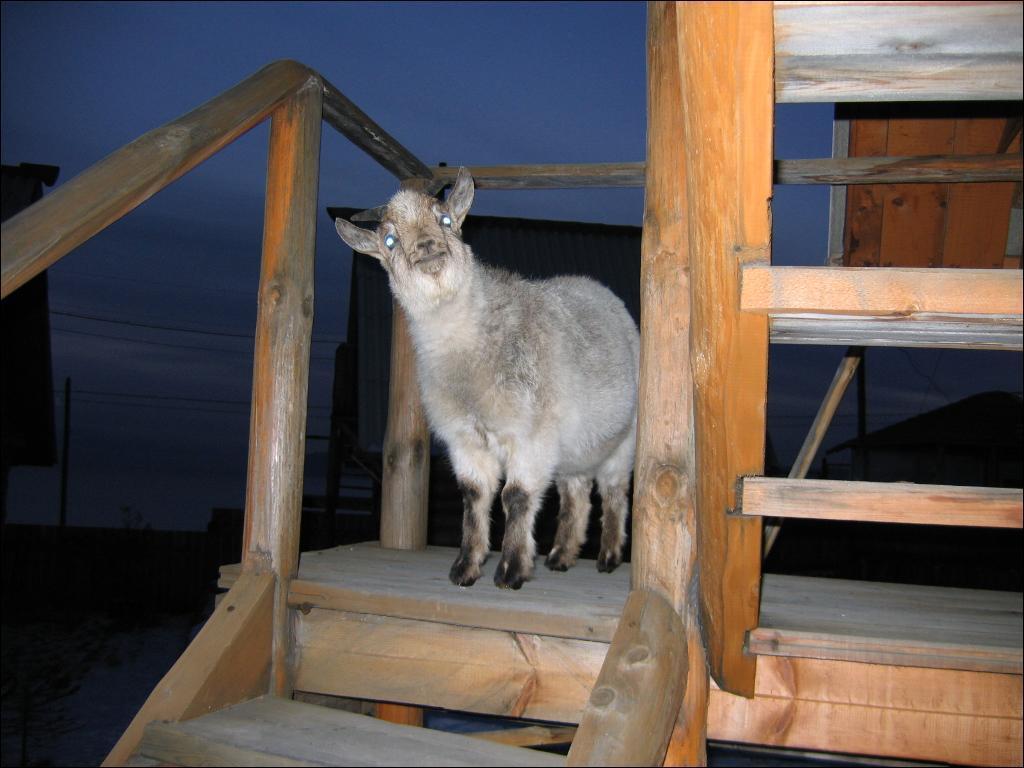Could you give a brief overview of what you see in this image? In the image I can see a sheep on a wooden surface. In the background I can see poles, wires, the sky and some other objects. 